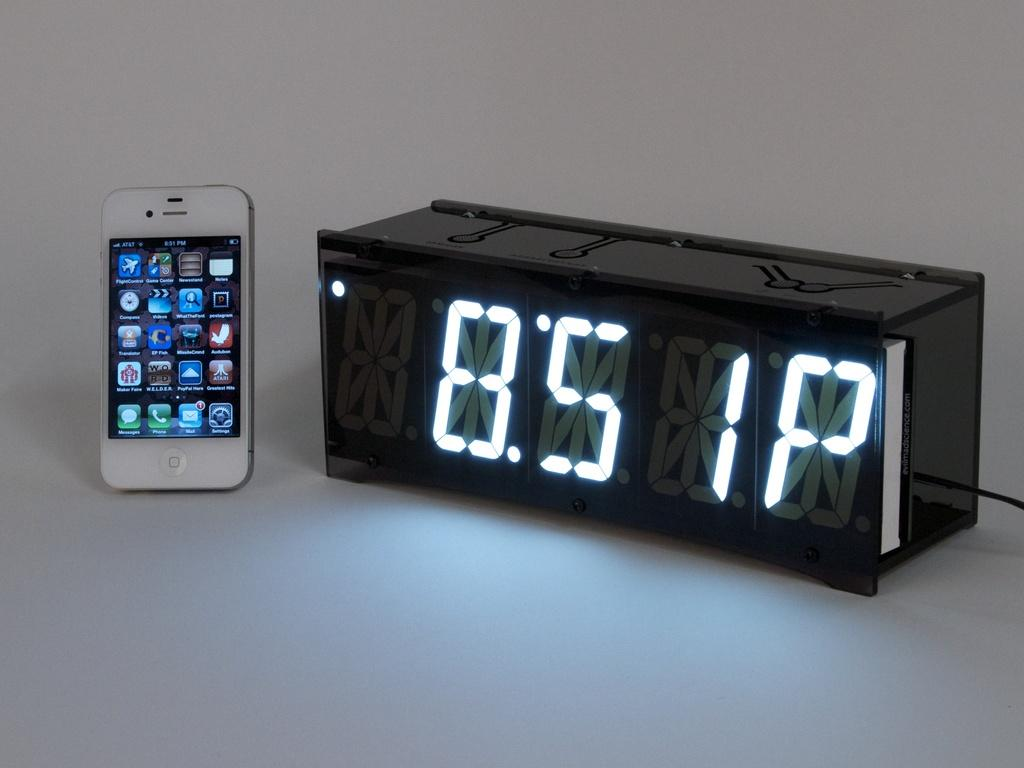Provide a one-sentence caption for the provided image. A digital clock displaying the time as 8:51PM in white LED. 